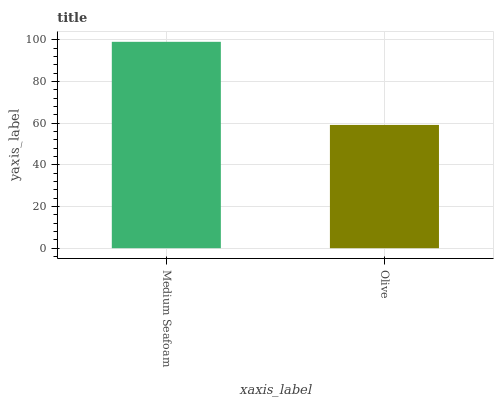Is Olive the minimum?
Answer yes or no. Yes. Is Medium Seafoam the maximum?
Answer yes or no. Yes. Is Olive the maximum?
Answer yes or no. No. Is Medium Seafoam greater than Olive?
Answer yes or no. Yes. Is Olive less than Medium Seafoam?
Answer yes or no. Yes. Is Olive greater than Medium Seafoam?
Answer yes or no. No. Is Medium Seafoam less than Olive?
Answer yes or no. No. Is Medium Seafoam the high median?
Answer yes or no. Yes. Is Olive the low median?
Answer yes or no. Yes. Is Olive the high median?
Answer yes or no. No. Is Medium Seafoam the low median?
Answer yes or no. No. 